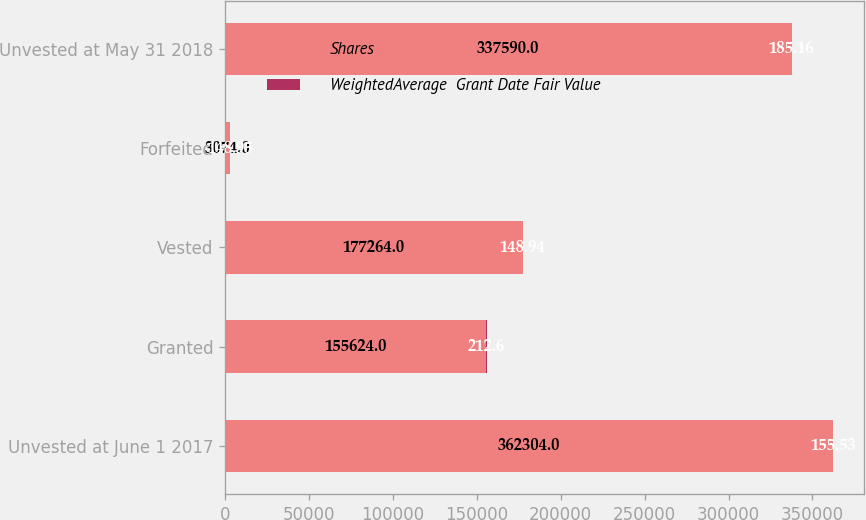<chart> <loc_0><loc_0><loc_500><loc_500><stacked_bar_chart><ecel><fcel>Unvested at June 1 2017<fcel>Granted<fcel>Vested<fcel>Forfeited<fcel>Unvested at May 31 2018<nl><fcel>Shares<fcel>362304<fcel>155624<fcel>177264<fcel>3074<fcel>337590<nl><fcel>WeightedAverage  Grant Date Fair Value<fcel>155.53<fcel>212.6<fcel>148.94<fcel>148.95<fcel>185.16<nl></chart> 